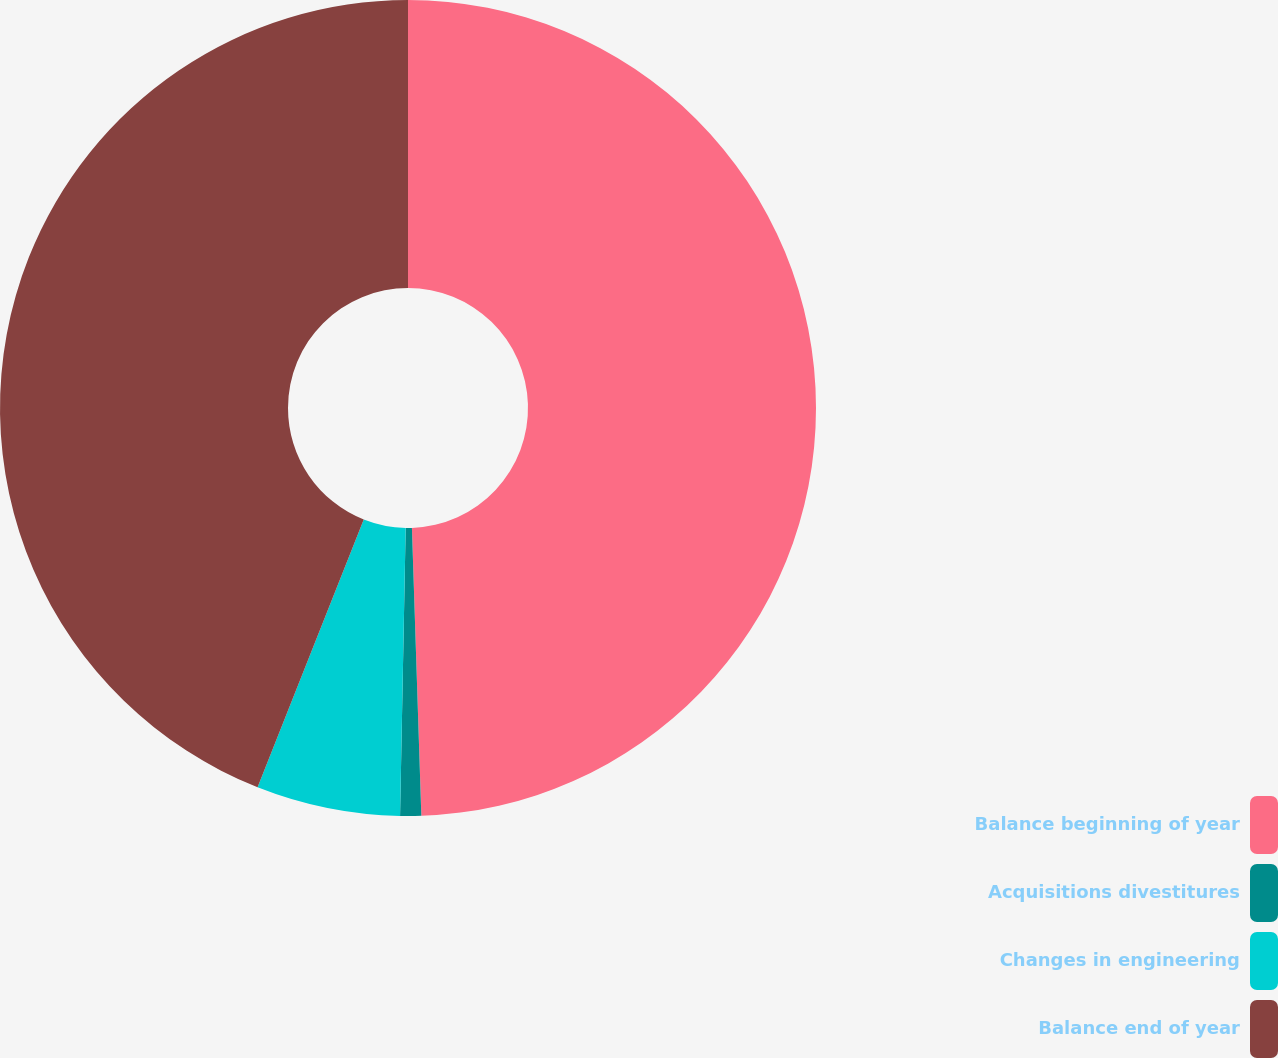Convert chart. <chart><loc_0><loc_0><loc_500><loc_500><pie_chart><fcel>Balance beginning of year<fcel>Acquisitions divestitures<fcel>Changes in engineering<fcel>Balance end of year<nl><fcel>49.48%<fcel>0.83%<fcel>5.7%<fcel>43.99%<nl></chart> 